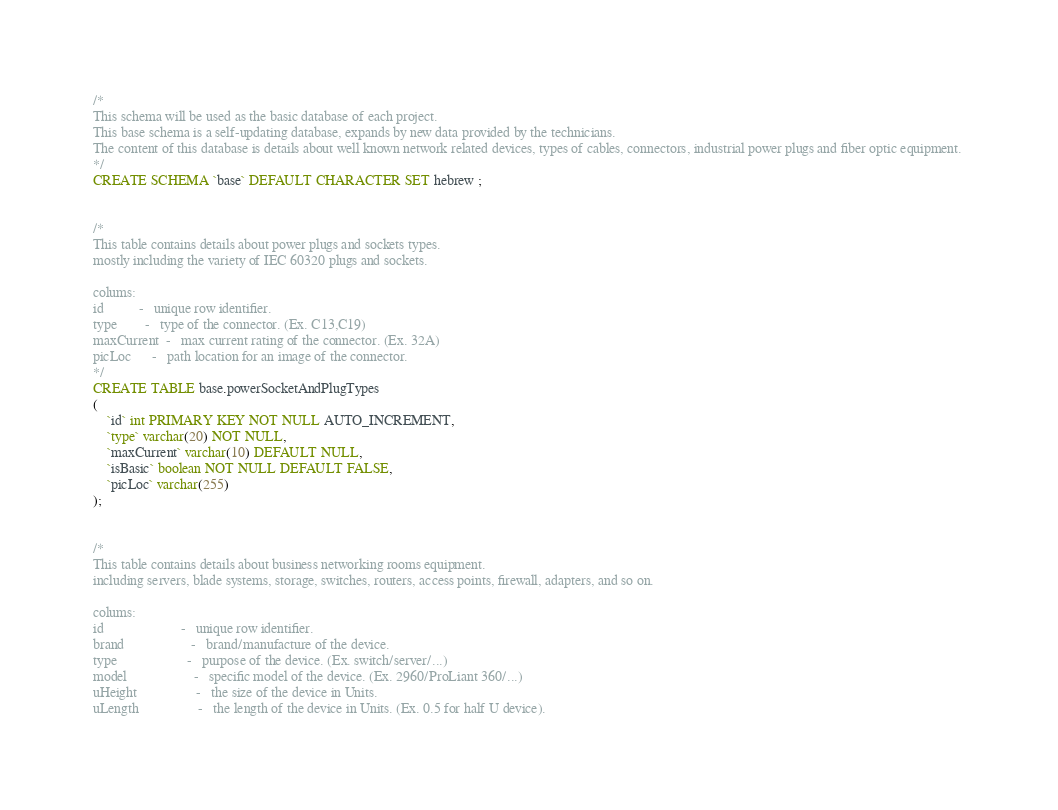Convert code to text. <code><loc_0><loc_0><loc_500><loc_500><_SQL_>/*
This schema will be used as the basic database of each project.
This base schema is a self-updating database, expands by new data provided by the technicians.
The content of this database is details about well known network related devices, types of cables, connectors, industrial power plugs and fiber optic equipment. 
*/
CREATE SCHEMA `base` DEFAULT CHARACTER SET hebrew ;


/*
This table contains details about power plugs and sockets types.
mostly including the variety of IEC 60320 plugs and sockets.

colums:
id 			- 	unique row identifier.
type 		- 	type of the connector. (Ex. C13,C19)
maxCurrent	- 	max current rating of the connector. (Ex. 32A)
picLoc		-	path location for an image of the connector.
*/
CREATE TABLE base.powerSocketAndPlugTypes
(
	`id` int PRIMARY KEY NOT NULL AUTO_INCREMENT,
	`type` varchar(20) NOT NULL,
	`maxCurrent` varchar(10) DEFAULT NULL,
	`isBasic` boolean NOT NULL DEFAULT FALSE,
	`picLoc` varchar(255)
);


/*
This table contains details about business networking rooms equipment.
including servers, blade systems, storage, switches, routers, access points, firewall, adapters, and so on.

colums:
id 						- 	unique row identifier.
brand 					- 	brand/manufacture of the device.
type 					- 	purpose of the device. (Ex. switch/server/...)
model			 		- 	specific model of the device. (Ex. 2960/ProLiant 360/...)
uHeight					- 	the size of the device in Units.
uLength					- 	the length of the device in Units. (Ex. 0.5 for half U device).</code> 